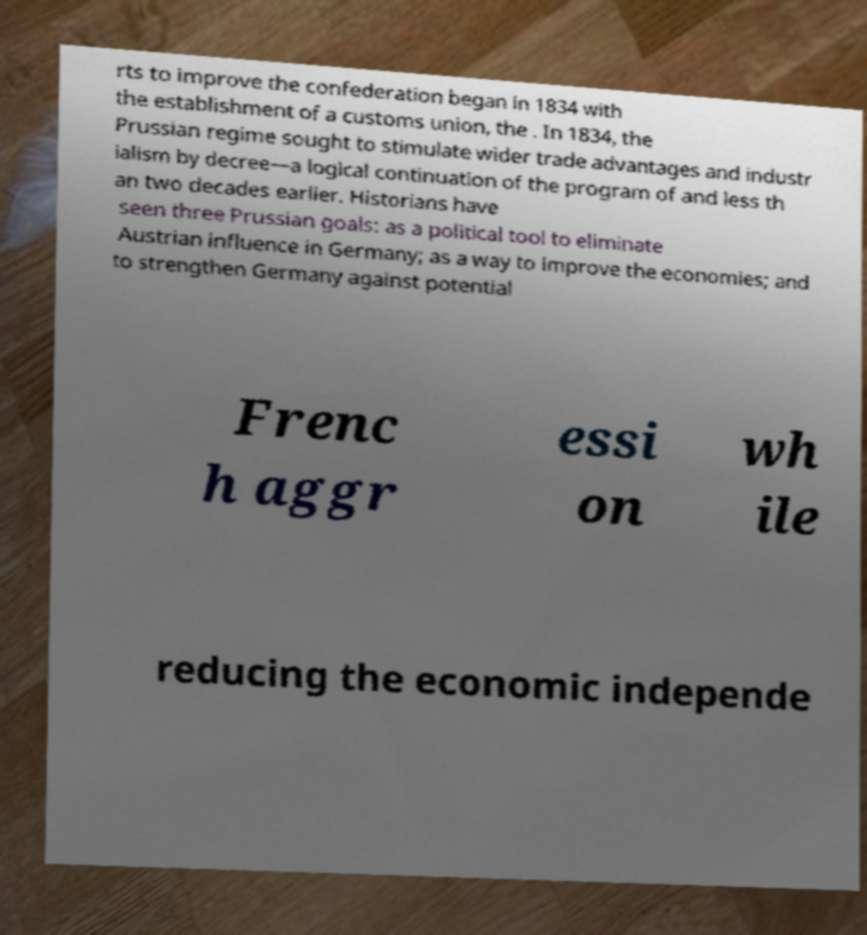What messages or text are displayed in this image? I need them in a readable, typed format. rts to improve the confederation began in 1834 with the establishment of a customs union, the . In 1834, the Prussian regime sought to stimulate wider trade advantages and industr ialism by decree—a logical continuation of the program of and less th an two decades earlier. Historians have seen three Prussian goals: as a political tool to eliminate Austrian influence in Germany; as a way to improve the economies; and to strengthen Germany against potential Frenc h aggr essi on wh ile reducing the economic independe 